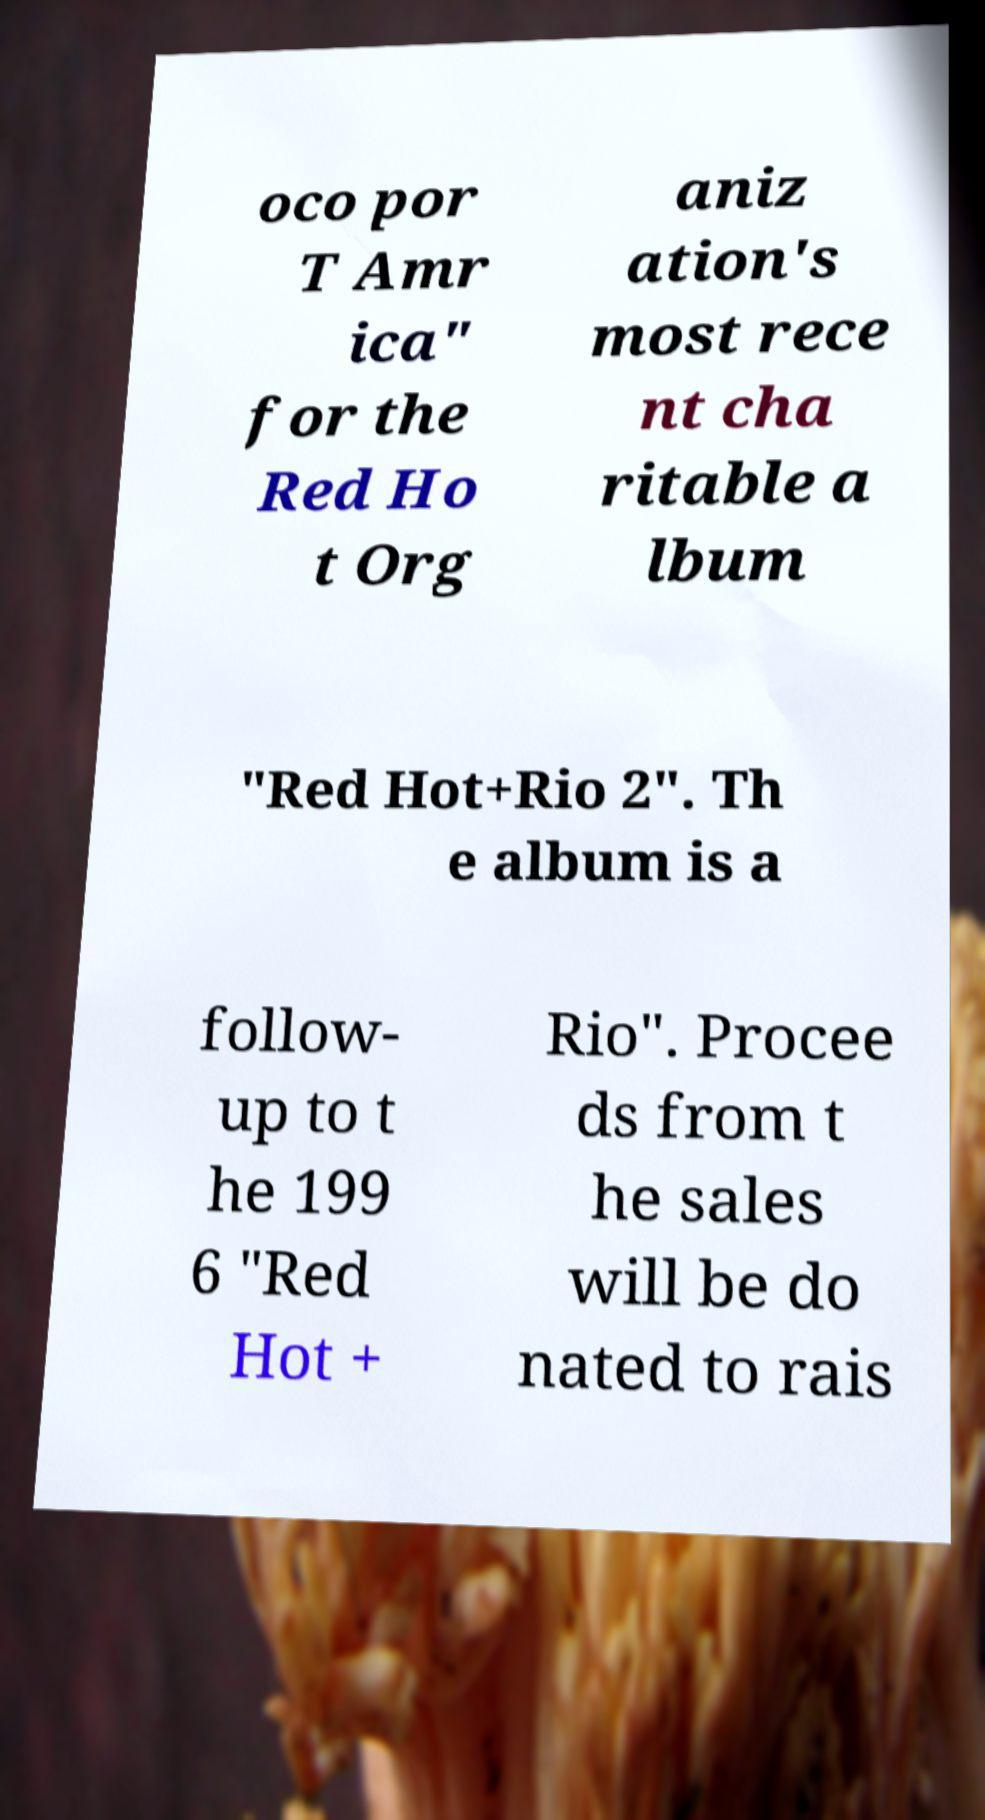Could you extract and type out the text from this image? oco por T Amr ica" for the Red Ho t Org aniz ation's most rece nt cha ritable a lbum "Red Hot+Rio 2". Th e album is a follow- up to t he 199 6 "Red Hot + Rio". Procee ds from t he sales will be do nated to rais 